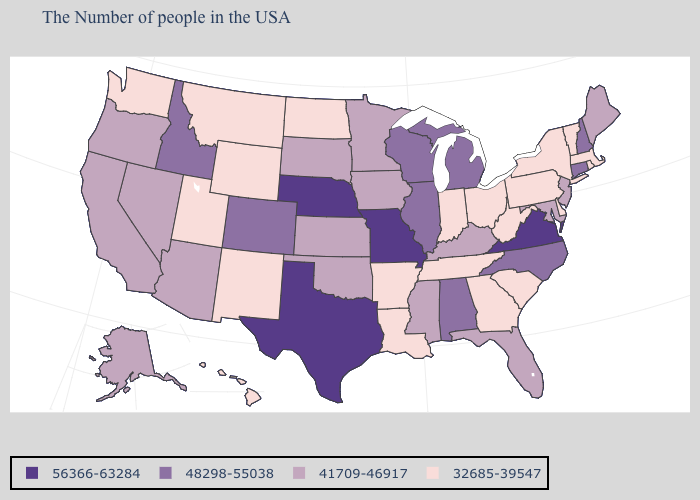Does the map have missing data?
Give a very brief answer. No. Among the states that border Tennessee , which have the highest value?
Give a very brief answer. Virginia, Missouri. Among the states that border Ohio , does Michigan have the lowest value?
Write a very short answer. No. What is the value of Utah?
Answer briefly. 32685-39547. Name the states that have a value in the range 48298-55038?
Answer briefly. New Hampshire, Connecticut, North Carolina, Michigan, Alabama, Wisconsin, Illinois, Colorado, Idaho. Does the map have missing data?
Answer briefly. No. Does South Carolina have the same value as South Dakota?
Be succinct. No. Name the states that have a value in the range 56366-63284?
Give a very brief answer. Virginia, Missouri, Nebraska, Texas. Does the first symbol in the legend represent the smallest category?
Quick response, please. No. Does Indiana have the lowest value in the MidWest?
Short answer required. Yes. What is the value of Vermont?
Quick response, please. 32685-39547. What is the value of Washington?
Give a very brief answer. 32685-39547. Name the states that have a value in the range 41709-46917?
Keep it brief. Maine, New Jersey, Maryland, Florida, Kentucky, Mississippi, Minnesota, Iowa, Kansas, Oklahoma, South Dakota, Arizona, Nevada, California, Oregon, Alaska. Does Arizona have a higher value than Indiana?
Answer briefly. Yes. Name the states that have a value in the range 32685-39547?
Quick response, please. Massachusetts, Rhode Island, Vermont, New York, Delaware, Pennsylvania, South Carolina, West Virginia, Ohio, Georgia, Indiana, Tennessee, Louisiana, Arkansas, North Dakota, Wyoming, New Mexico, Utah, Montana, Washington, Hawaii. 